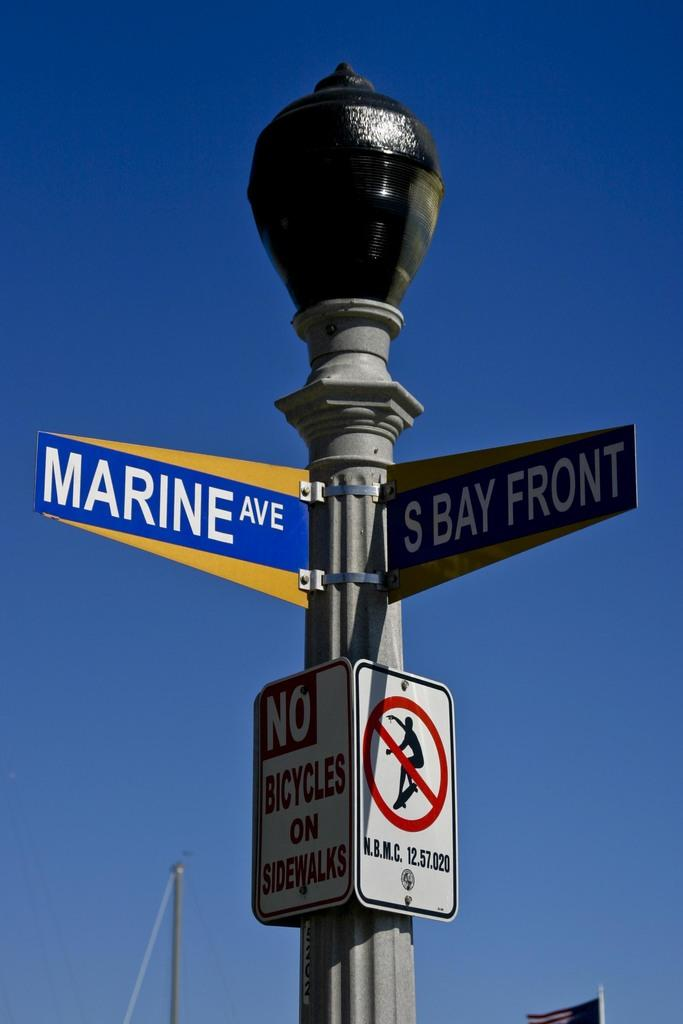<image>
Render a clear and concise summary of the photo. Two street signs designate the intersection of Marine Ave and S Bay Front. 